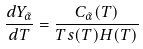<formula> <loc_0><loc_0><loc_500><loc_500>\frac { d Y _ { \tilde { \alpha } } } { d T } = \frac { C _ { \tilde { \alpha } } ( T ) } { T s ( T ) H ( T ) }</formula> 